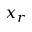Convert formula to latex. <formula><loc_0><loc_0><loc_500><loc_500>x _ { r }</formula> 